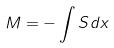<formula> <loc_0><loc_0><loc_500><loc_500>M = - \int S d x</formula> 